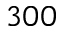<formula> <loc_0><loc_0><loc_500><loc_500>3 0 0</formula> 